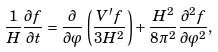<formula> <loc_0><loc_0><loc_500><loc_500>\frac { 1 } { H } \frac { \partial f } { \partial t } = \frac { \partial } { \partial \varphi } \left ( \frac { V ^ { \prime } f } { 3 H ^ { 2 } } \right ) + \frac { H ^ { 2 } } { 8 \pi ^ { 2 } } \frac { \partial ^ { 2 } f } { \partial \varphi ^ { 2 } } ,</formula> 